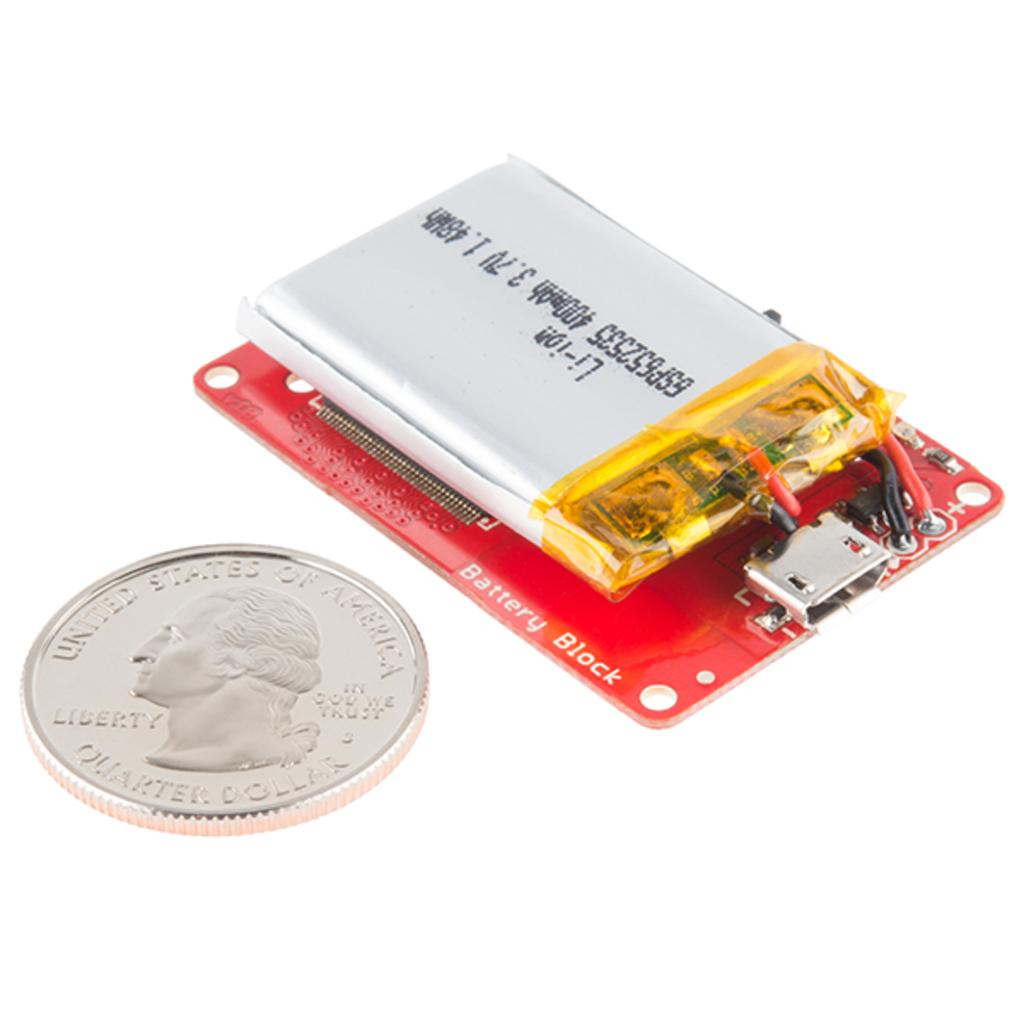Provide a one-sentence caption for the provided image. A quarter laying beside a silver battery on a battery block. 